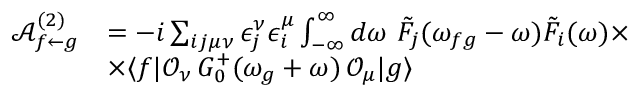Convert formula to latex. <formula><loc_0><loc_0><loc_500><loc_500>\begin{array} { r l } { \mathcal { A } _ { f \leftarrow g } ^ { ( 2 ) } } & { = - i \sum _ { i j \mu \nu } \epsilon _ { j } ^ { \nu } \epsilon _ { i } ^ { \mu } \int _ { - \infty } ^ { \infty } d \omega \, \tilde { F } _ { j } ( \omega _ { f g } - \omega ) \tilde { F } _ { i } ( \omega ) \times } \\ & { \times \langle f | \mathcal { O } _ { \nu } \, G _ { 0 } ^ { + } ( \omega _ { g } + \omega ) \, \mathcal { O } _ { \mu } | g \rangle } \end{array}</formula> 